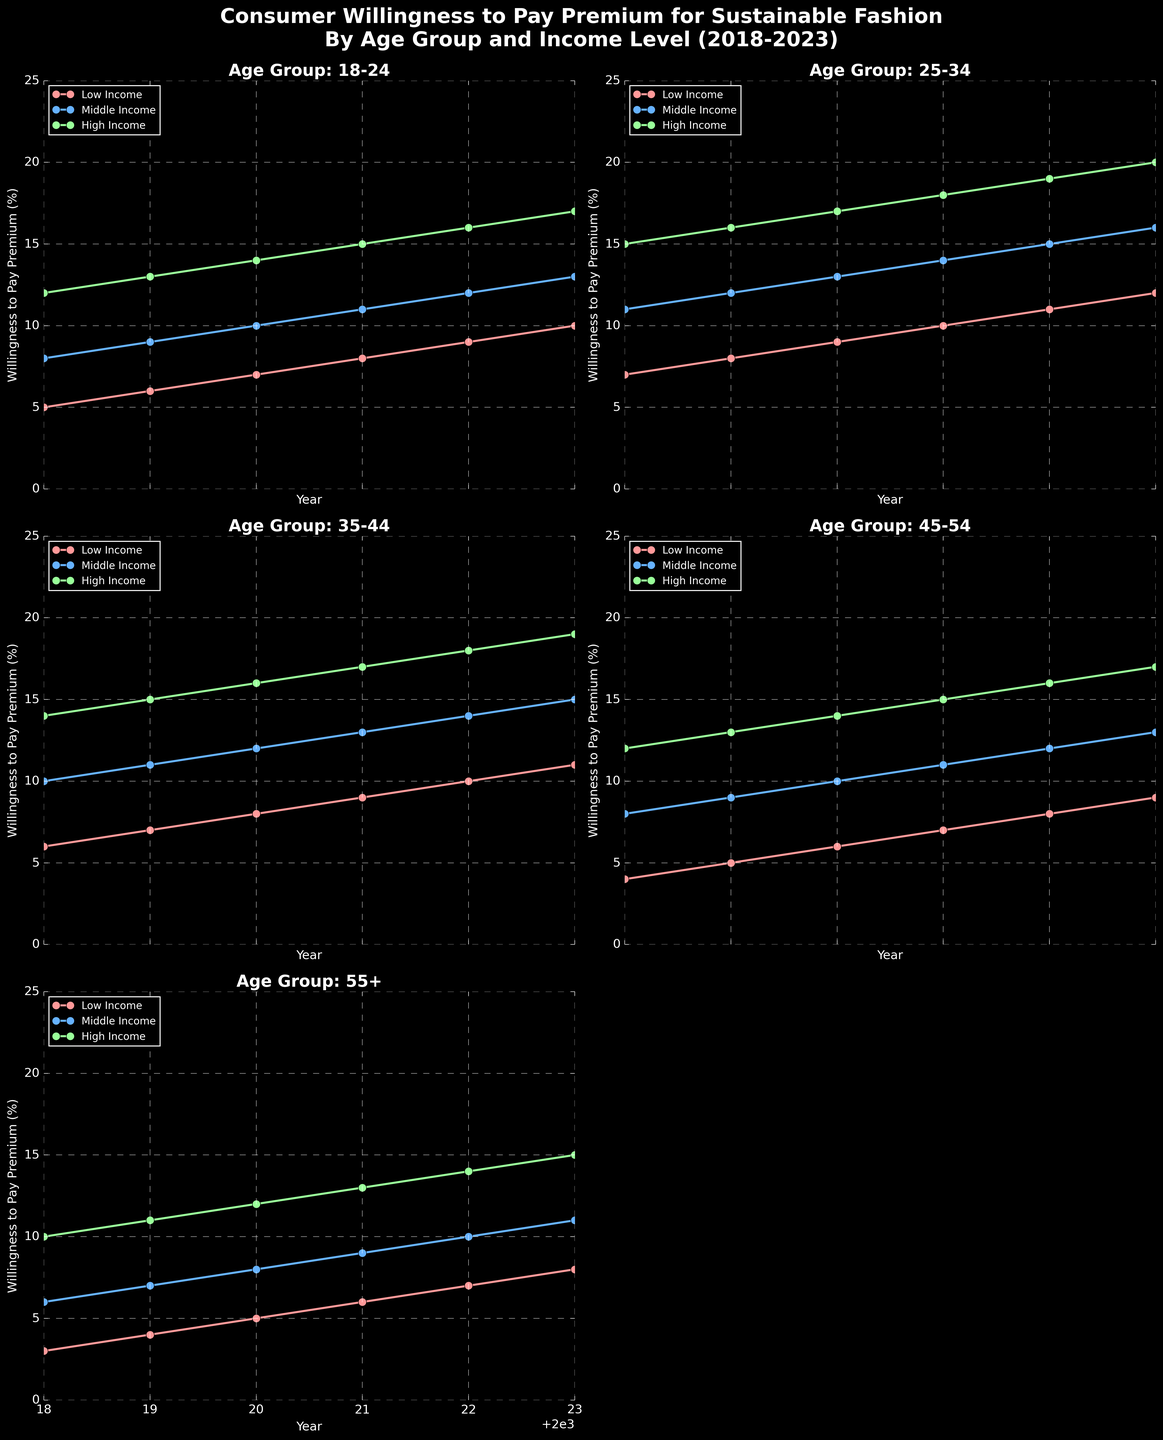What's the trend in willingness to pay premium among 18-24 middle-income consumers from 2018 to 2023? The plotted line for 18-24 middle-income consumers shows a steady increase. From 2018 to 2023, it rises from 8% to 13%.
Answer: It increases Which age group in high-income levels shows the highest willingness to pay premium in 2023? Among high-income consumers in 2023, the 25-34 age group shows the highest percentage willingness to pay a premium at 20%.
Answer: 25-34 In 2020, which age group exhibited the lowest willingness to pay premium among low-income consumers? In 2020, the data points for low-income consumers across age groups show that the 55+ age group has the lowest percentage willingness to pay a premium at 5%.
Answer: 55+ Compare the willingness to pay a premium between 35-44 high-income and 45-54 middle-income consumers in 2022. For 2022, the percentage for 35-44 high-income consumers is 18%, and for 45-54 middle-income consumers, it is 12%. Thus, 35-44 high-income consumers are higher.
Answer: 35-44 high-income What is the average willingness to pay a premium across all income levels for 18-24 age group in 2020? In 2020, the values for 18-24 low, middle, and high-income groups are 7%, 10%, and 14% respectively. The average is (7+10+14)/3 = 10.33%.
Answer: 10.33% Which income group among the 55+ age category consistently shows a higher willingness to pay a premium from 2018 to 2023? For the 55+ age category, the high-income group consistently shows higher values each year ranging from 10% in 2018 to 15% in 2023.
Answer: High income In 2019, which age group and income level saw a higher willingness to pay premium: 25-34 low-income or 45-54 high-income? In 2019, 25-34 low-income consumers have 8%, whereas 45-54 high-income consumers have 13%. Therefore, the 45-54 high-income group is higher.
Answer: 45-54 high income What's the difference in willingness to pay premium in 2023 between high-income 25-34 and low-income 45-54 age groups? For 2023, high-income 25-34 consumers are at 20%, and low-income 45-54 consumers are at 9%. The difference is 20% - 9% = 11%.
Answer: 11% How did the willingness to pay premium for 35-44 middle-income consumers change from 2018 to 2023? The data shows an increase from 10% in 2018 to 15% in 2023 for 35-44 middle-income consumers.
Answer: It increased What is the cumulative increase in willingness to pay a premium from 2018 to 2023 for the 55+ middle-income age group? For 55+ middle-income consumers, the value increased from 6% in 2018 to 11% in 2023, a cumulative increase of 11% - 6% = 5%.
Answer: 5% 